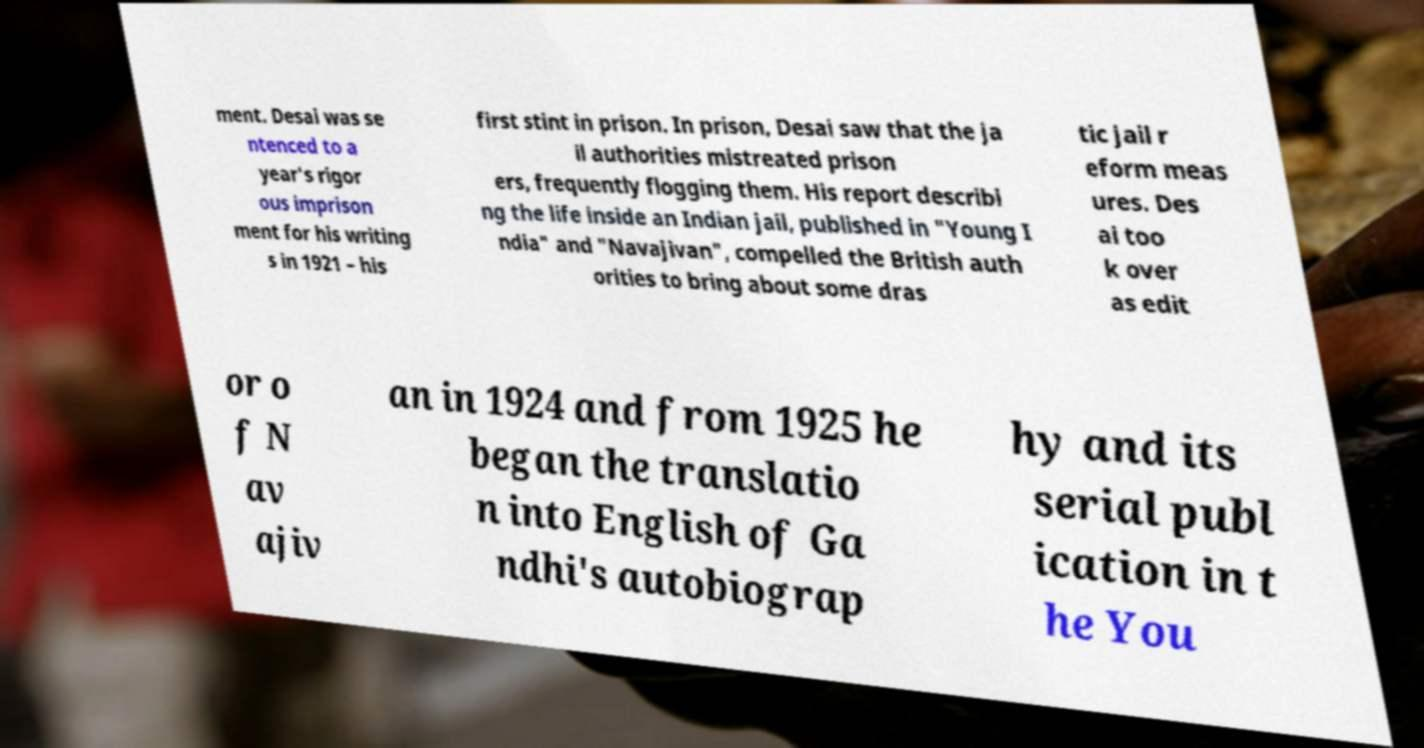Please read and relay the text visible in this image. What does it say? ment. Desai was se ntenced to a year's rigor ous imprison ment for his writing s in 1921 – his first stint in prison. In prison, Desai saw that the ja il authorities mistreated prison ers, frequently flogging them. His report describi ng the life inside an Indian jail, published in "Young I ndia" and "Navajivan", compelled the British auth orities to bring about some dras tic jail r eform meas ures. Des ai too k over as edit or o f N av ajiv an in 1924 and from 1925 he began the translatio n into English of Ga ndhi's autobiograp hy and its serial publ ication in t he You 